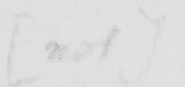What text is written in this handwritten line? [ not ] 